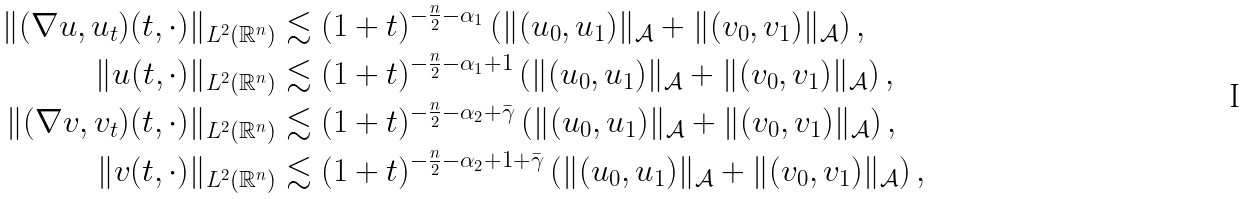Convert formula to latex. <formula><loc_0><loc_0><loc_500><loc_500>\| ( \nabla u , u _ { t } ) ( t , \cdot ) \| _ { L ^ { 2 } ( \mathbb { R } ^ { n } ) } & \lesssim ( 1 + t ) ^ { - \frac { n } { 2 } - \alpha _ { 1 } } \left ( \| ( u _ { 0 } , u _ { 1 } ) \| _ { \mathcal { A } } + \| ( v _ { 0 } , v _ { 1 } ) \| _ { \mathcal { A } } \right ) , \\ \| u ( t , \cdot ) \| _ { L ^ { 2 } ( \mathbb { R } ^ { n } ) } & \lesssim ( 1 + t ) ^ { - \frac { n } { 2 } - \alpha _ { 1 } + 1 } \left ( \| ( u _ { 0 } , u _ { 1 } ) \| _ { \mathcal { A } } + \| ( v _ { 0 } , v _ { 1 } ) \| _ { \mathcal { A } } \right ) , \\ \| ( \nabla v , v _ { t } ) ( t , \cdot ) \| _ { L ^ { 2 } ( \mathbb { R } ^ { n } ) } & \lesssim ( 1 + t ) ^ { - \frac { n } { 2 } - \alpha _ { 2 } + \bar { \gamma } } \left ( \| ( u _ { 0 } , u _ { 1 } ) \| _ { \mathcal { A } } + \| ( v _ { 0 } , v _ { 1 } ) \| _ { \mathcal { A } } \right ) , \\ \| v ( t , \cdot ) \| _ { L ^ { 2 } ( \mathbb { R } ^ { n } ) } & \lesssim ( 1 + t ) ^ { - \frac { n } { 2 } - \alpha _ { 2 } + 1 + \bar { \gamma } } \left ( \| ( u _ { 0 } , u _ { 1 } ) \| _ { \mathcal { A } } + \| ( v _ { 0 } , v _ { 1 } ) \| _ { \mathcal { A } } \right ) ,</formula> 